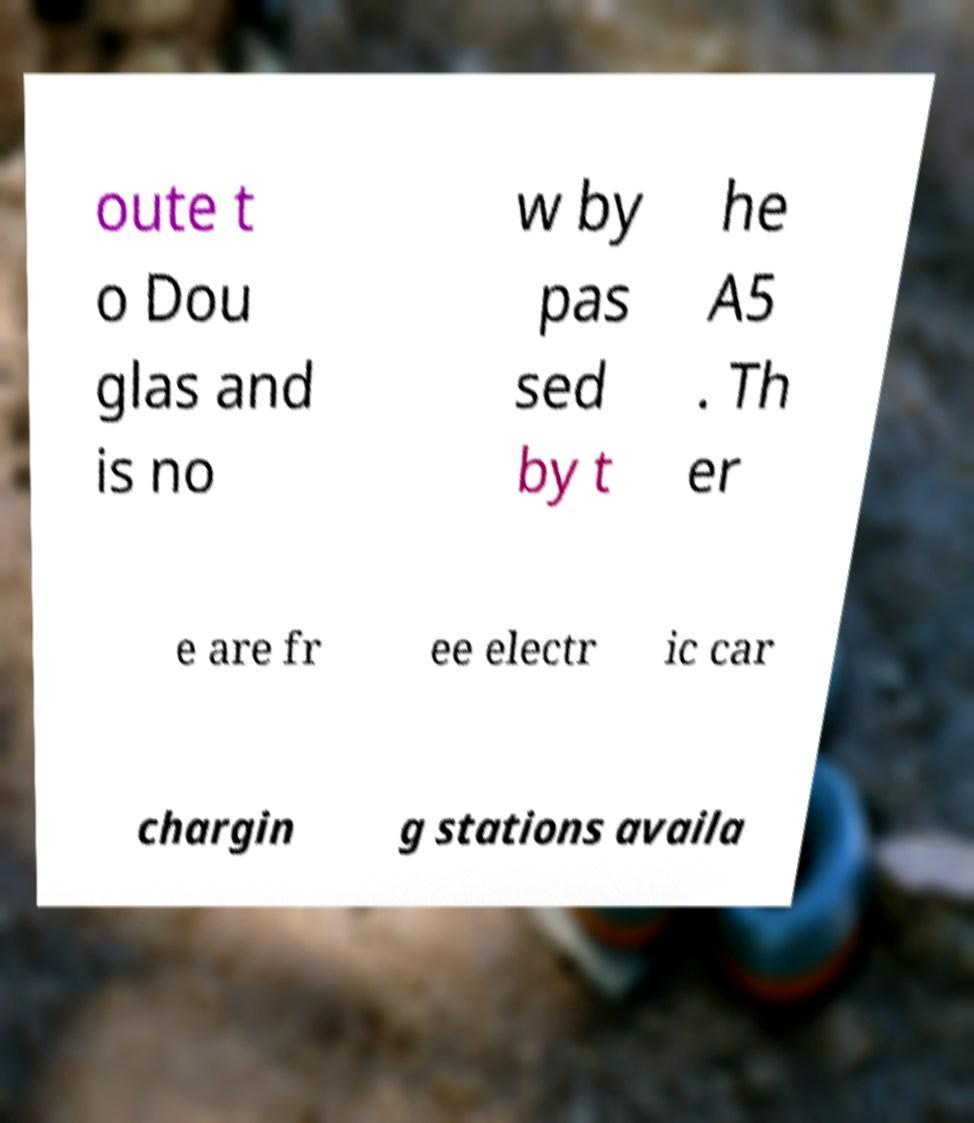Can you read and provide the text displayed in the image?This photo seems to have some interesting text. Can you extract and type it out for me? oute t o Dou glas and is no w by pas sed by t he A5 . Th er e are fr ee electr ic car chargin g stations availa 